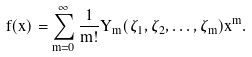<formula> <loc_0><loc_0><loc_500><loc_500>f ( x ) = \sum _ { m = 0 } ^ { \infty } \frac { 1 } { m ! } Y _ { m } ( \zeta _ { 1 } , \zeta _ { 2 } , \dots , \zeta _ { m } ) x ^ { m } .</formula> 